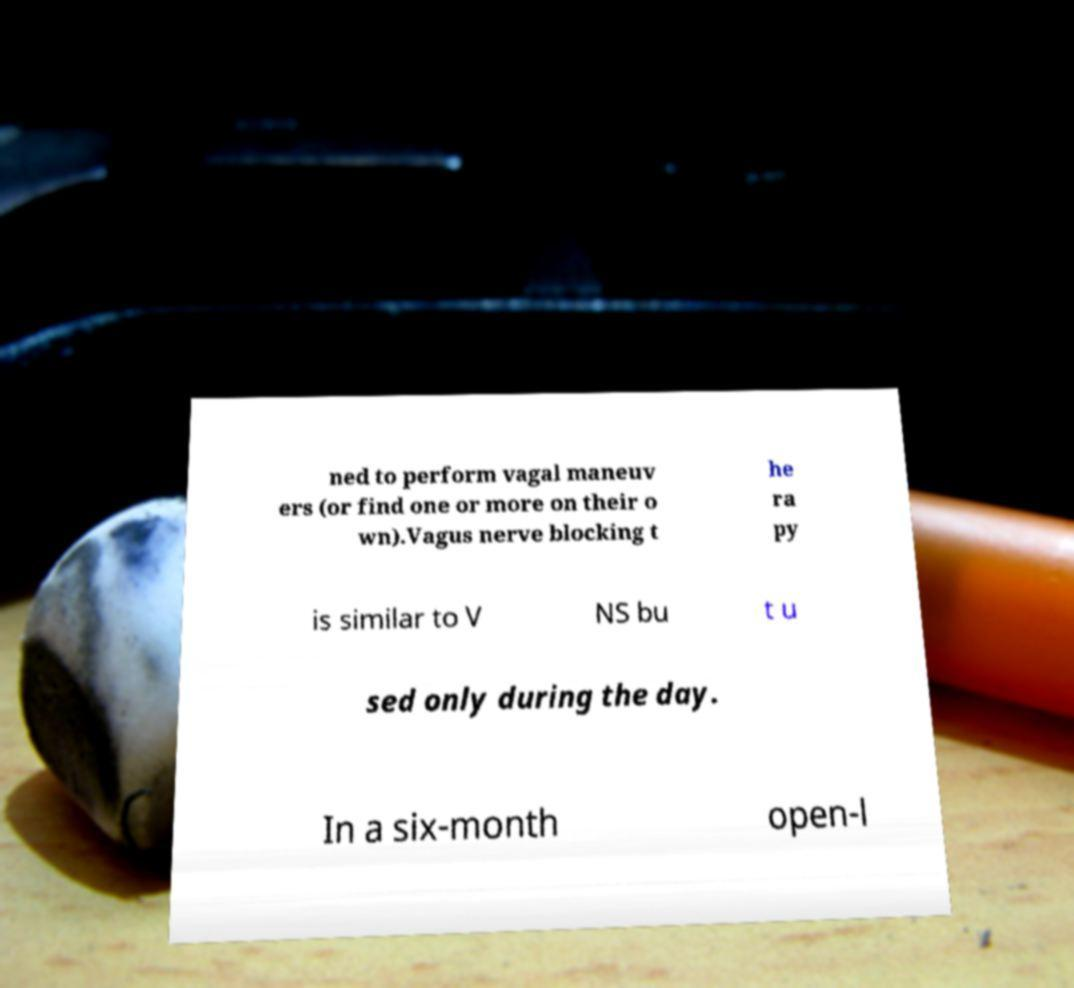Please identify and transcribe the text found in this image. ned to perform vagal maneuv ers (or find one or more on their o wn).Vagus nerve blocking t he ra py is similar to V NS bu t u sed only during the day. In a six-month open-l 